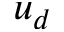<formula> <loc_0><loc_0><loc_500><loc_500>u _ { d }</formula> 